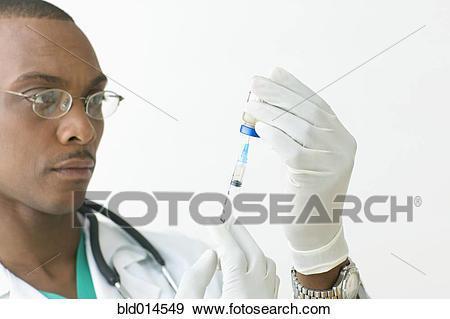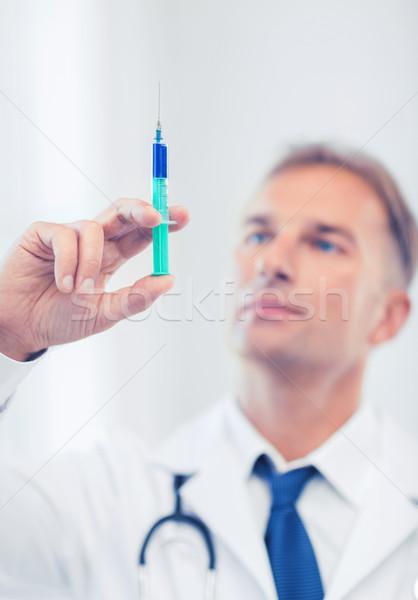The first image is the image on the left, the second image is the image on the right. Evaluate the accuracy of this statement regarding the images: "There is a woman visible in one of the images.". Is it true? Answer yes or no. No. The first image is the image on the left, the second image is the image on the right. For the images shown, is this caption "Two doctors are looking at syringes." true? Answer yes or no. Yes. 